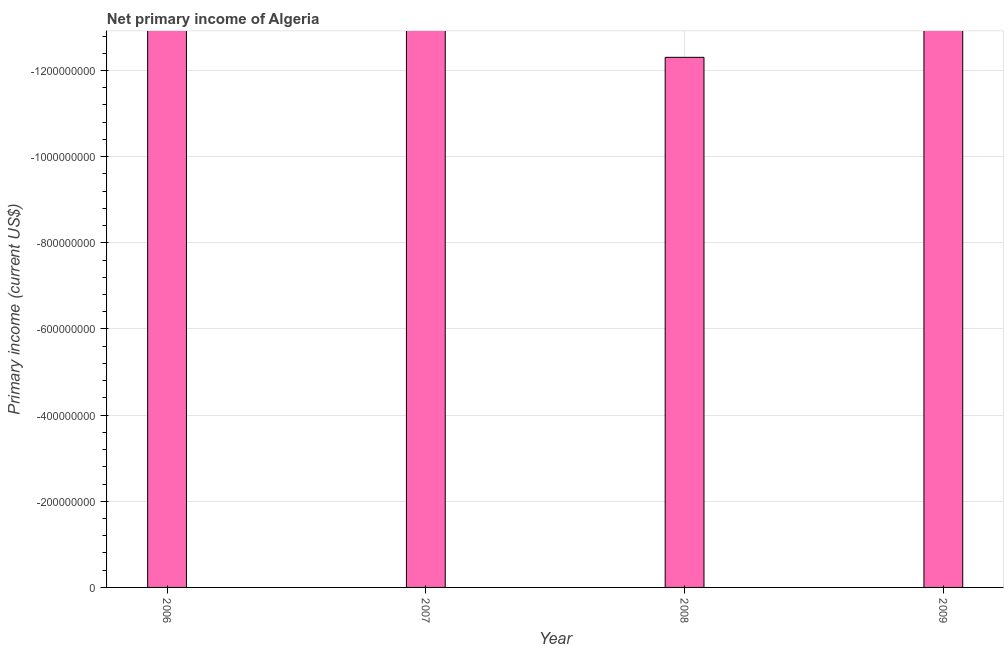Does the graph contain grids?
Keep it short and to the point. Yes. What is the title of the graph?
Your answer should be compact. Net primary income of Algeria. What is the label or title of the Y-axis?
Your response must be concise. Primary income (current US$). What is the sum of the amount of primary income?
Provide a short and direct response. 0. In how many years, is the amount of primary income greater than the average amount of primary income taken over all years?
Ensure brevity in your answer.  0. Are all the bars in the graph horizontal?
Your answer should be very brief. No. How many years are there in the graph?
Ensure brevity in your answer.  4. What is the difference between two consecutive major ticks on the Y-axis?
Provide a succinct answer. 2.00e+08. What is the Primary income (current US$) in 2006?
Your answer should be very brief. 0. What is the Primary income (current US$) of 2007?
Your response must be concise. 0. What is the Primary income (current US$) in 2008?
Make the answer very short. 0. What is the Primary income (current US$) in 2009?
Give a very brief answer. 0. 